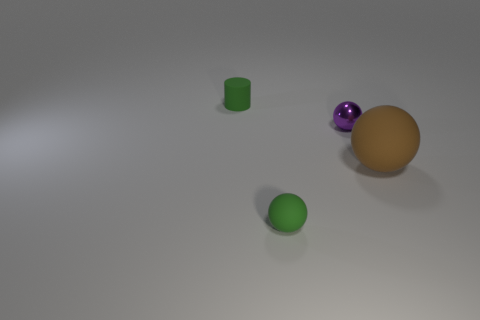Add 2 tiny purple metal objects. How many objects exist? 6 Subtract all cylinders. How many objects are left? 3 Add 3 large rubber spheres. How many large rubber spheres are left? 4 Add 4 small green rubber cylinders. How many small green rubber cylinders exist? 5 Subtract 1 green cylinders. How many objects are left? 3 Subtract all tiny rubber objects. Subtract all small green matte balls. How many objects are left? 1 